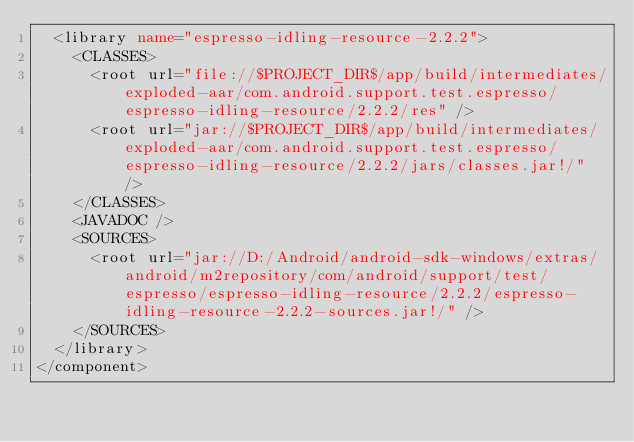Convert code to text. <code><loc_0><loc_0><loc_500><loc_500><_XML_>  <library name="espresso-idling-resource-2.2.2">
    <CLASSES>
      <root url="file://$PROJECT_DIR$/app/build/intermediates/exploded-aar/com.android.support.test.espresso/espresso-idling-resource/2.2.2/res" />
      <root url="jar://$PROJECT_DIR$/app/build/intermediates/exploded-aar/com.android.support.test.espresso/espresso-idling-resource/2.2.2/jars/classes.jar!/" />
    </CLASSES>
    <JAVADOC />
    <SOURCES>
      <root url="jar://D:/Android/android-sdk-windows/extras/android/m2repository/com/android/support/test/espresso/espresso-idling-resource/2.2.2/espresso-idling-resource-2.2.2-sources.jar!/" />
    </SOURCES>
  </library>
</component></code> 